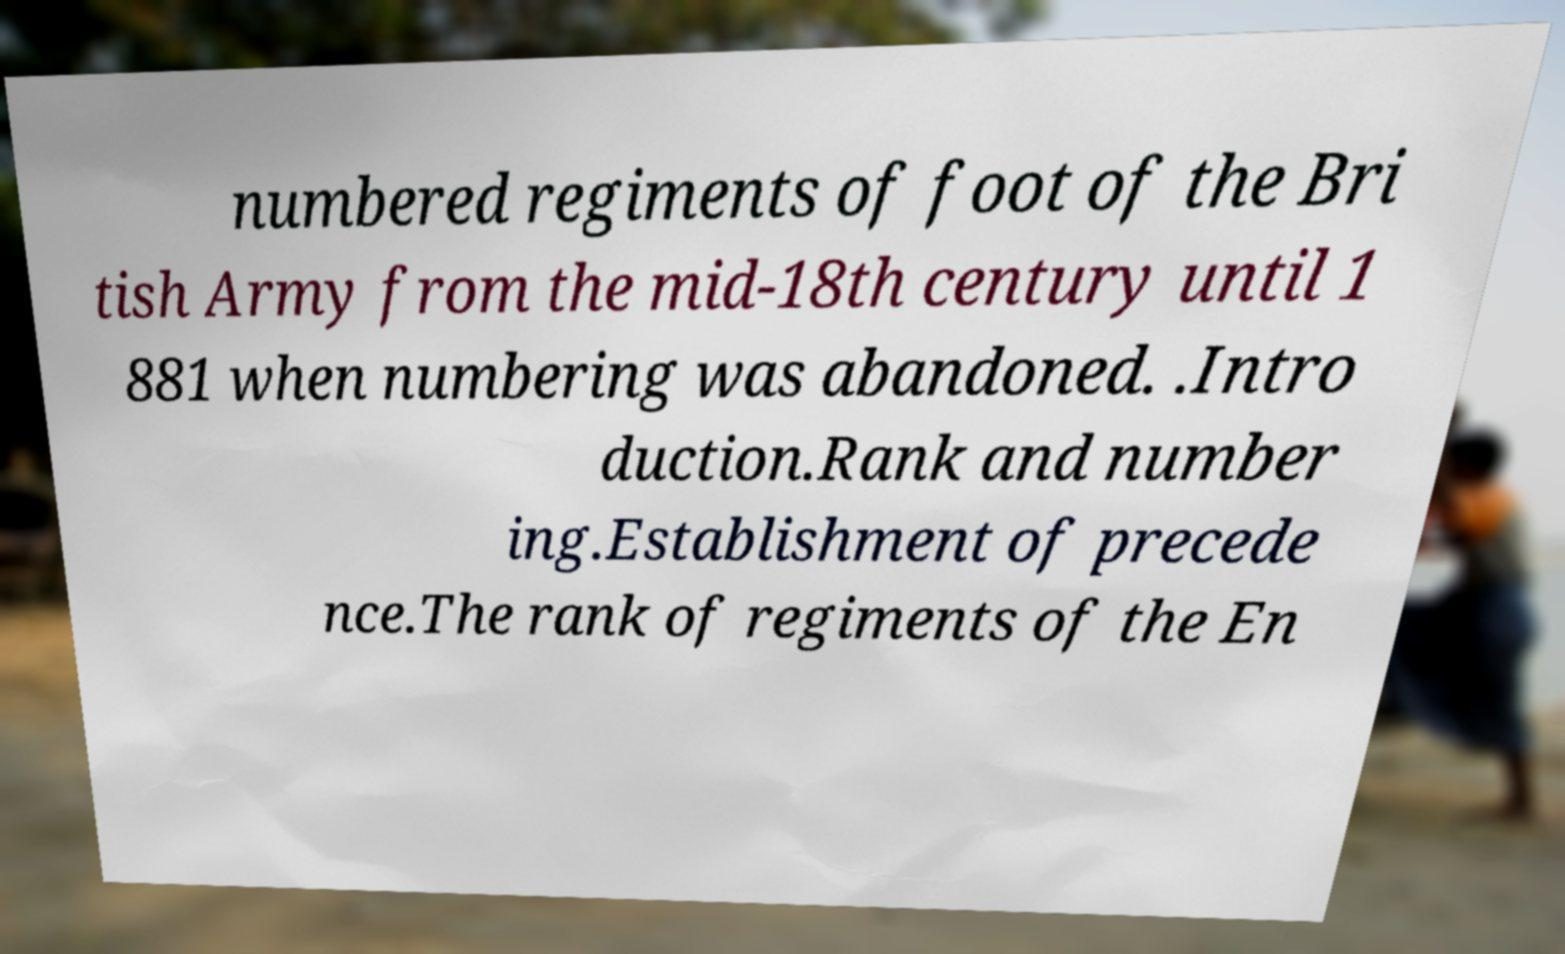I need the written content from this picture converted into text. Can you do that? numbered regiments of foot of the Bri tish Army from the mid-18th century until 1 881 when numbering was abandoned. .Intro duction.Rank and number ing.Establishment of precede nce.The rank of regiments of the En 